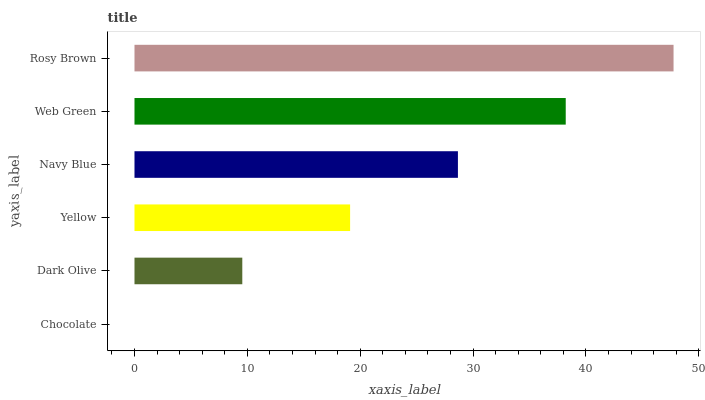Is Chocolate the minimum?
Answer yes or no. Yes. Is Rosy Brown the maximum?
Answer yes or no. Yes. Is Dark Olive the minimum?
Answer yes or no. No. Is Dark Olive the maximum?
Answer yes or no. No. Is Dark Olive greater than Chocolate?
Answer yes or no. Yes. Is Chocolate less than Dark Olive?
Answer yes or no. Yes. Is Chocolate greater than Dark Olive?
Answer yes or no. No. Is Dark Olive less than Chocolate?
Answer yes or no. No. Is Navy Blue the high median?
Answer yes or no. Yes. Is Yellow the low median?
Answer yes or no. Yes. Is Rosy Brown the high median?
Answer yes or no. No. Is Chocolate the low median?
Answer yes or no. No. 